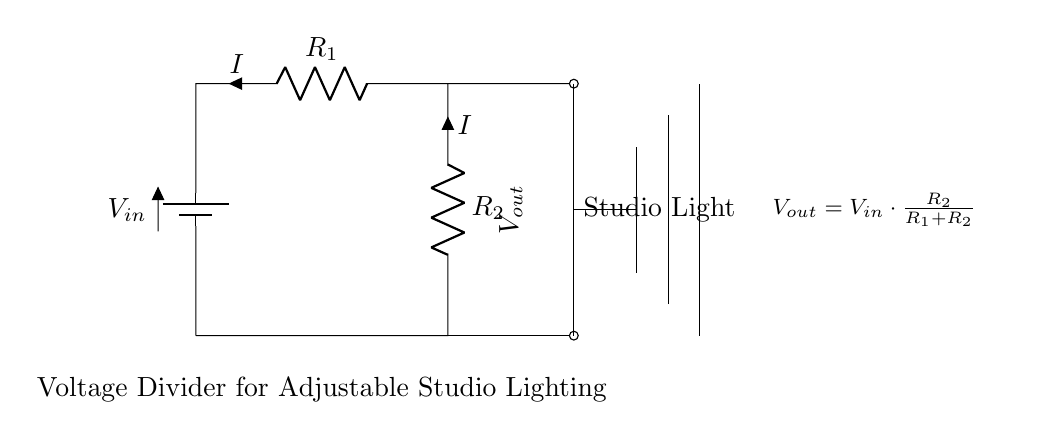What is the input voltage in the circuit? The input voltage is labeled as V_in in the circuit diagram, which indicates the source voltage connected to the voltage divider.
Answer: V_in What are the resistors in the circuit? The circuit contains two resistors, labeled as R_1 and R_2, positioned in series between the input voltage and ground.
Answer: R_1 and R_2 What does the output voltage depend on? The output voltage, V_out, depends on the ratio of the resistors R_2 and R_1. The formula given in the circuit states that V_out is proportional to R_2 and inversely proportional to the total resistance (R_1 + R_2).
Answer: R_2 and R_1 What will happen to the output voltage if R_2 is increased? If R_2 is increased while keeping R_1 constant, the output voltage V_out increases because it will increase the fraction of V_in according to the voltage divider formula.
Answer: V_out increases What is the main purpose of the voltage divider in this context? The primary purpose of the voltage divider in this circuit is to adjust the brightness levels of the studio lighting equipment by varying the output voltage, which directly affects the light intensity.
Answer: Adjusting brightness levels If R_2 is removed, what will be the output voltage? If R_2 is removed, the output voltage will be zero since there is no longer a path for current to flow through to ground, effectively short-circuiting the output.
Answer: Zero 